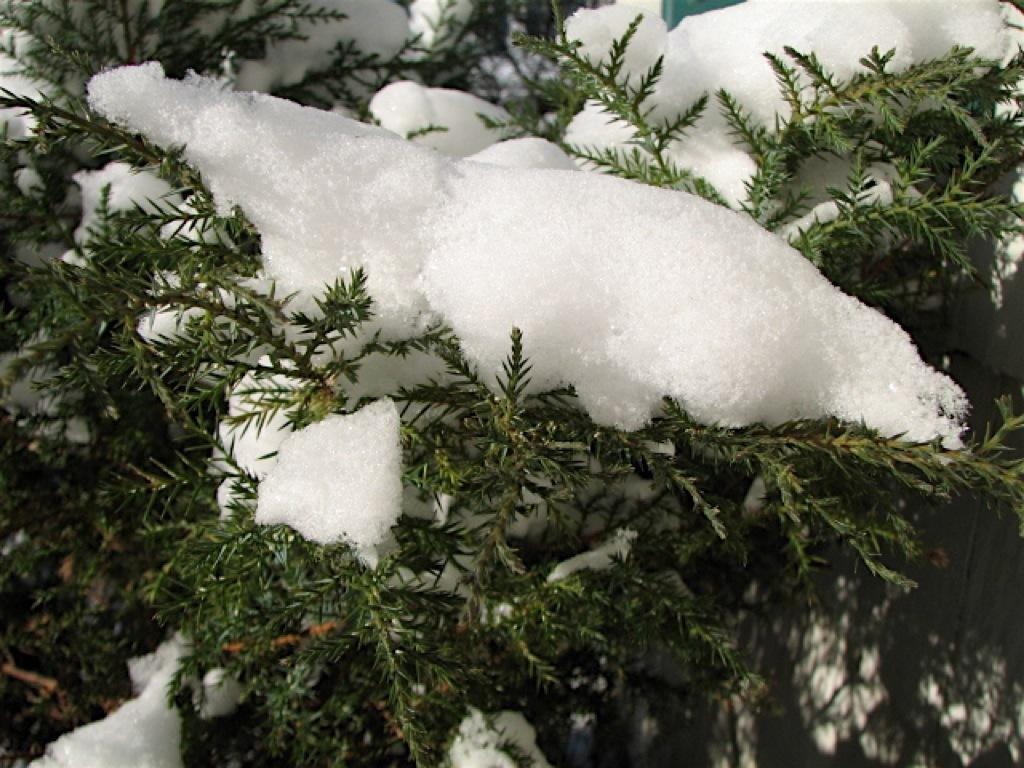What is the primary weather condition depicted in the image? There is snow in the image. What type of vegetation can be seen in the image? There are plants in the image. Who is the owner of the hammer in the image? There is no hammer present in the image. 